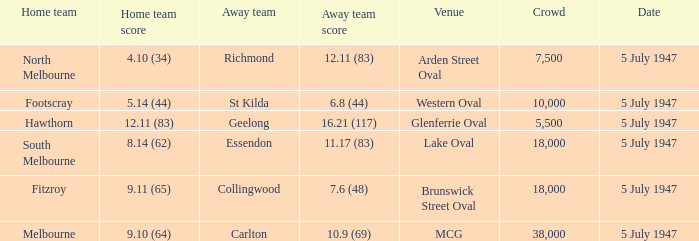What did the home team achieve when the away team scored 1 4.10 (34). 